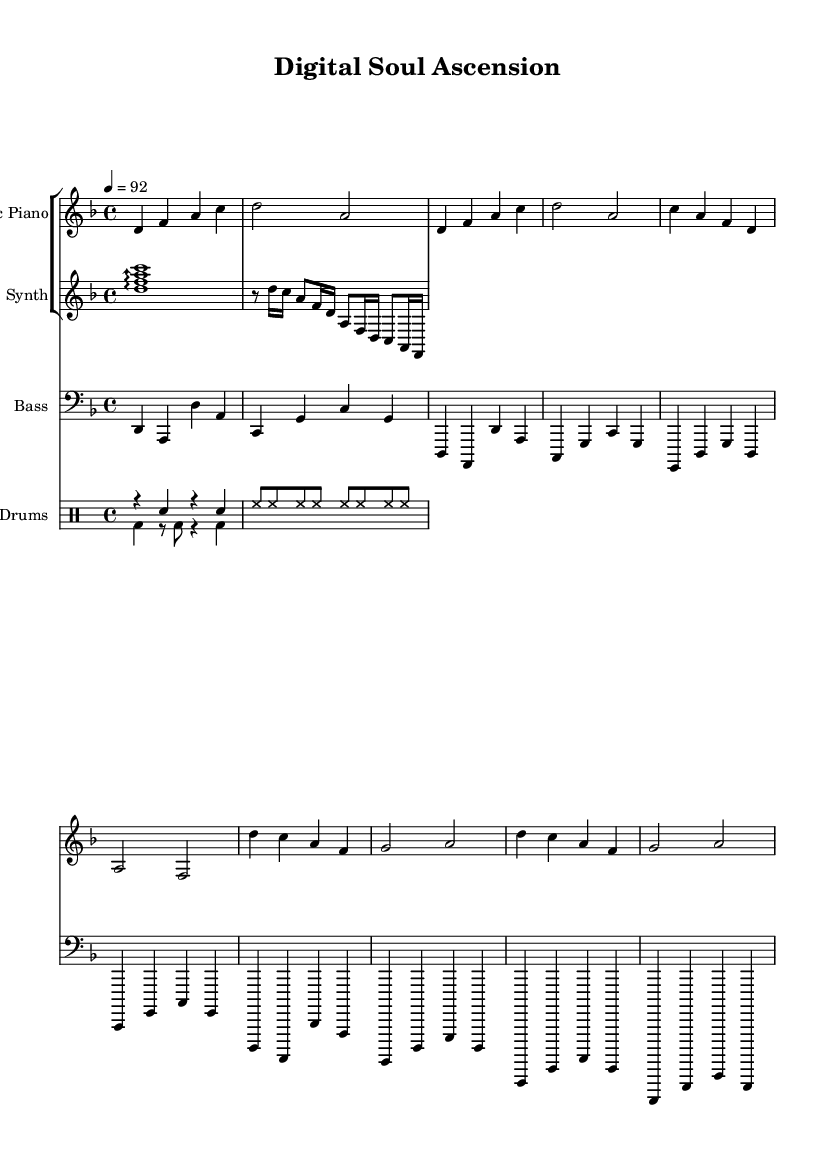What is the key signature of this music? The key signature is indicated on the left side of the staff. For this piece, it is D minor, which has one flat (B flat).
Answer: D minor What is the time signature of this music? The time signature can be found at the beginning of the staff. In this case, it is 4/4, meaning there are four beats in each measure, and the quarter note gets one beat.
Answer: 4/4 What is the tempo marking of this piece? The tempo marking is shown above the staff, indicating the speed of the piece. Here it reads "4 = 92," which means there are 92 beats per minute.
Answer: 92 How many measures are there in the electric piano section? By counting the bar lines in the electric piano part, we can determine the total measures; there are 8 measures in the electric piano section.
Answer: 8 What kind of electronic element is included alongside the traditional instruments in this piece? The music includes a 'synth' part, which typically incorporates electronic sounds and effects in contrast to the acoustic instruments.
Answer: Synth Describe the rhythmic pattern used in the drum section. The drum section consists of a combination of bass drum hits and snare hits. There are repeated patterns alternating between rests and hits, which create a driving rhythm typical of R&B.
Answer: Alternating bass and snare What does the use of an arpeggio in the synth part signify in the context of neo-soul fusion? The arpeggio in the synth part adds a flowing, melodic texture that enhances the harmonic richness while complementing the electronic vibe, which is a characteristic element of neo-soul fusion.
Answer: Flowing melodic texture 